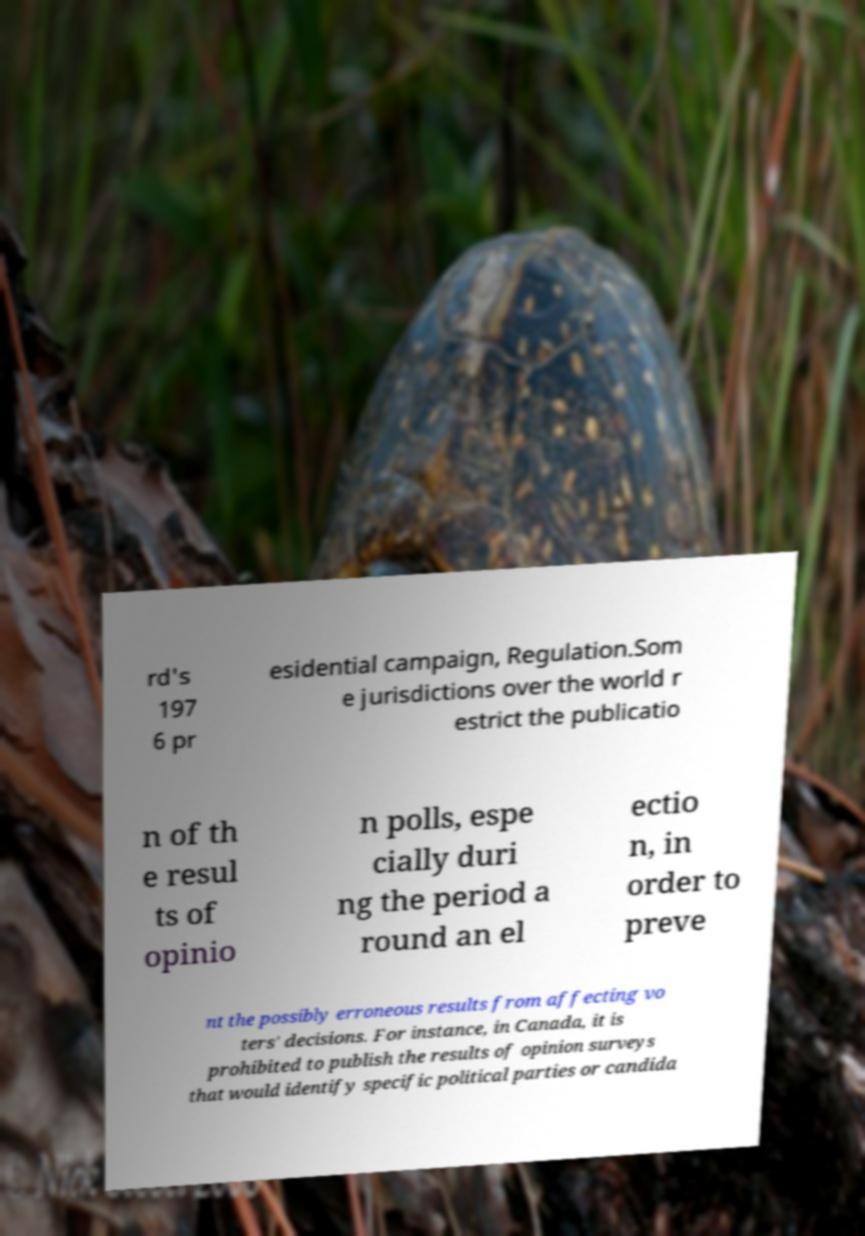What messages or text are displayed in this image? I need them in a readable, typed format. rd's 197 6 pr esidential campaign, Regulation.Som e jurisdictions over the world r estrict the publicatio n of th e resul ts of opinio n polls, espe cially duri ng the period a round an el ectio n, in order to preve nt the possibly erroneous results from affecting vo ters' decisions. For instance, in Canada, it is prohibited to publish the results of opinion surveys that would identify specific political parties or candida 